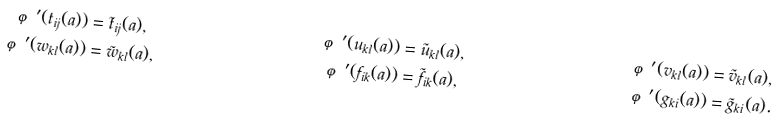<formula> <loc_0><loc_0><loc_500><loc_500>\varphi ^ { \prime } ( t _ { i j } ( a ) ) & = \tilde { t } _ { i j } ( a ) , & \varphi ^ { \prime } ( u _ { k l } ( a ) ) & = \tilde { u } _ { k l } ( a ) , & \varphi ^ { \prime } ( v _ { k l } ( a ) ) & = \tilde { v } _ { k l } ( a ) , \\ \varphi ^ { \prime } ( w _ { k l } ( a ) ) & = \tilde { w } _ { k l } ( a ) , & \varphi ^ { \prime } ( f _ { i k } ( a ) ) & = \tilde { f } _ { i k } ( a ) , & \varphi ^ { \prime } ( g _ { k i } ( a ) ) & = \tilde { g } _ { k i } ( a ) .</formula> 